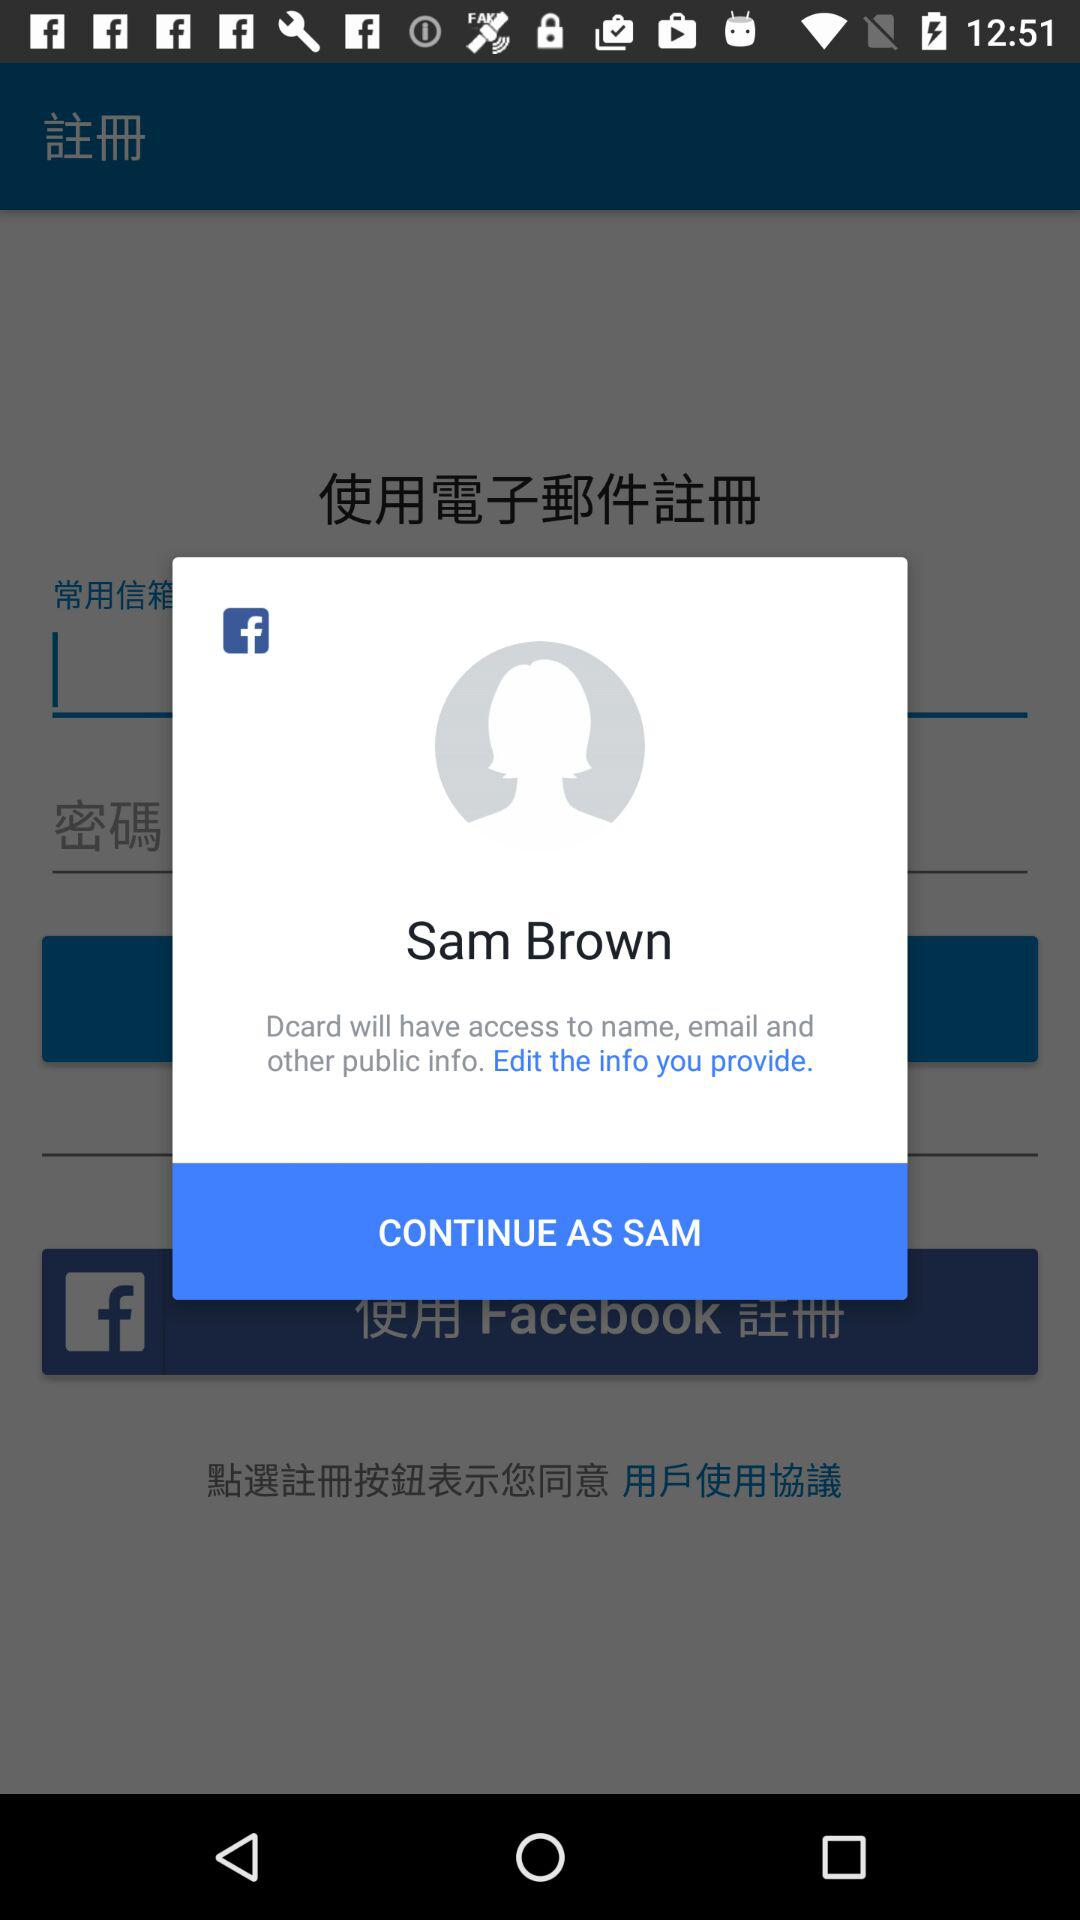What is the username? The username is Sam Brown. 